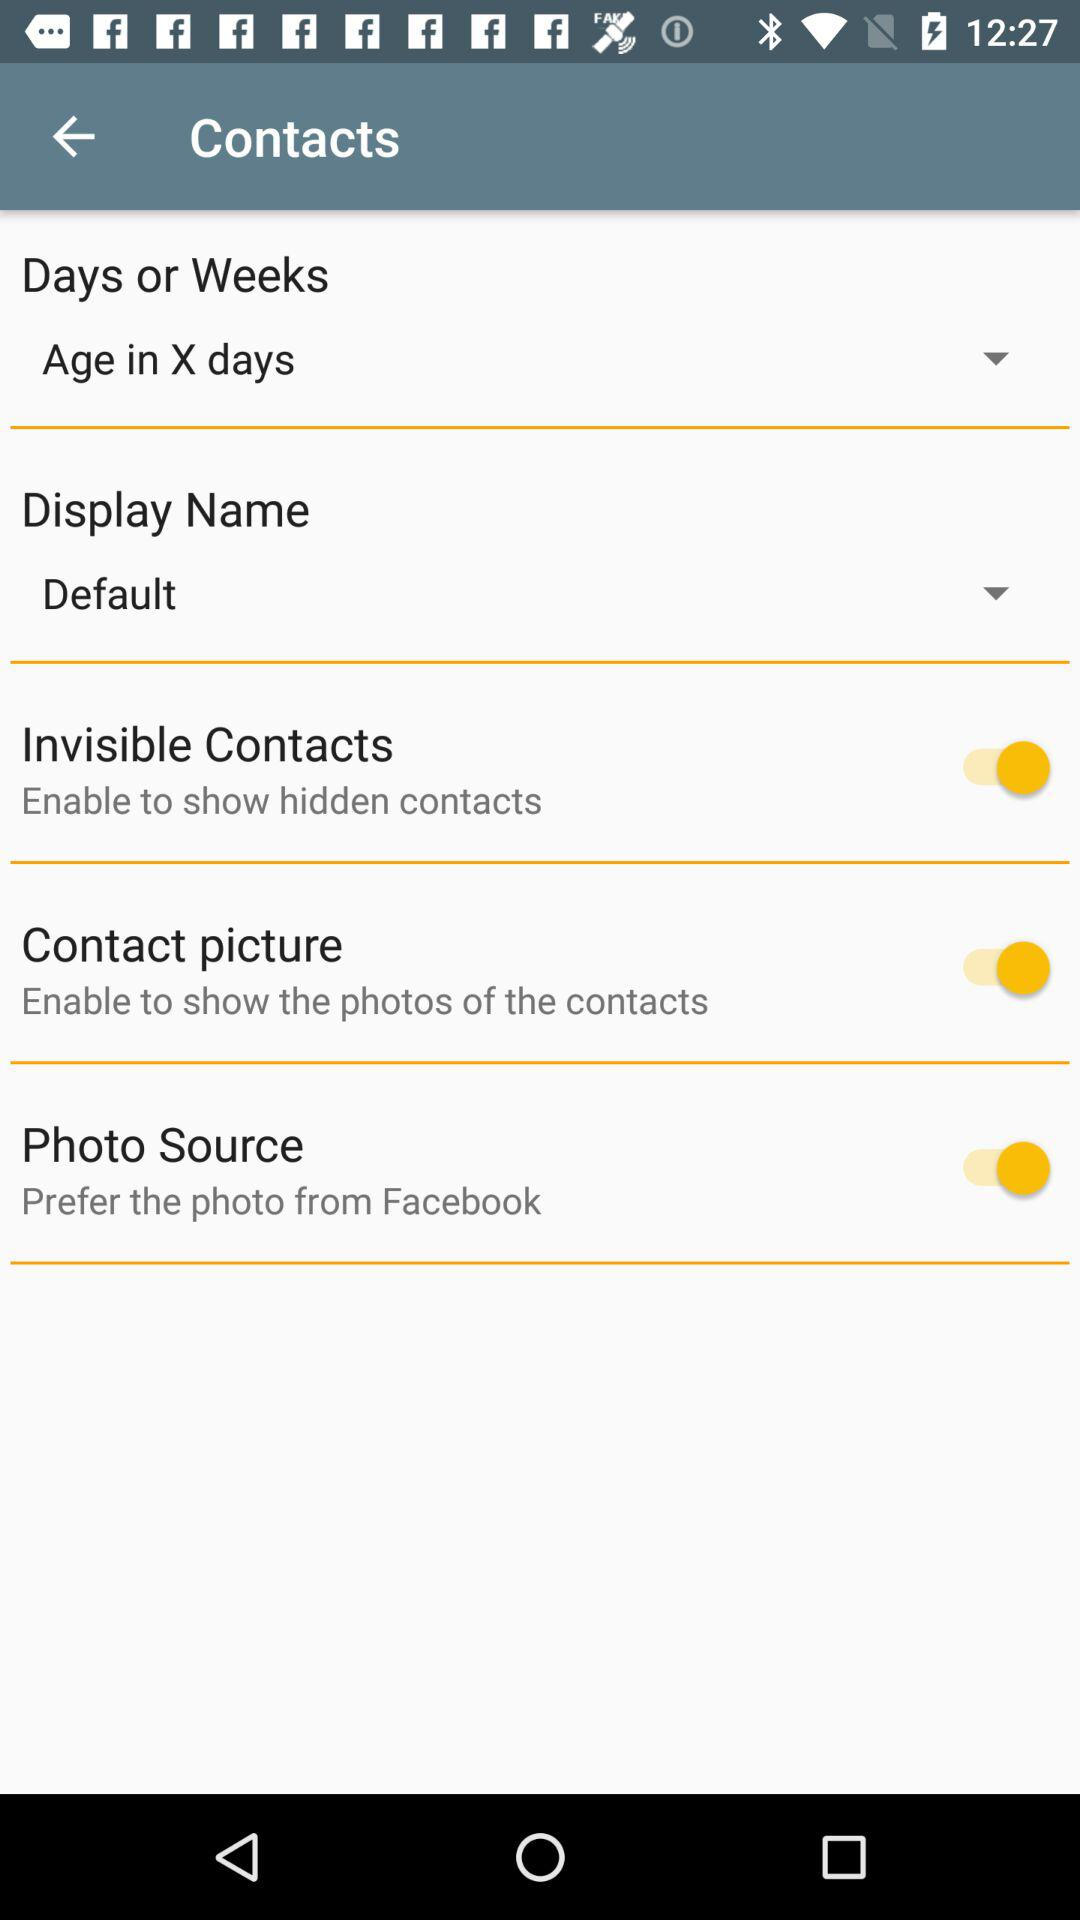Which options are available in the display name drop-down menu?
When the provided information is insufficient, respond with <no answer>. <no answer> 